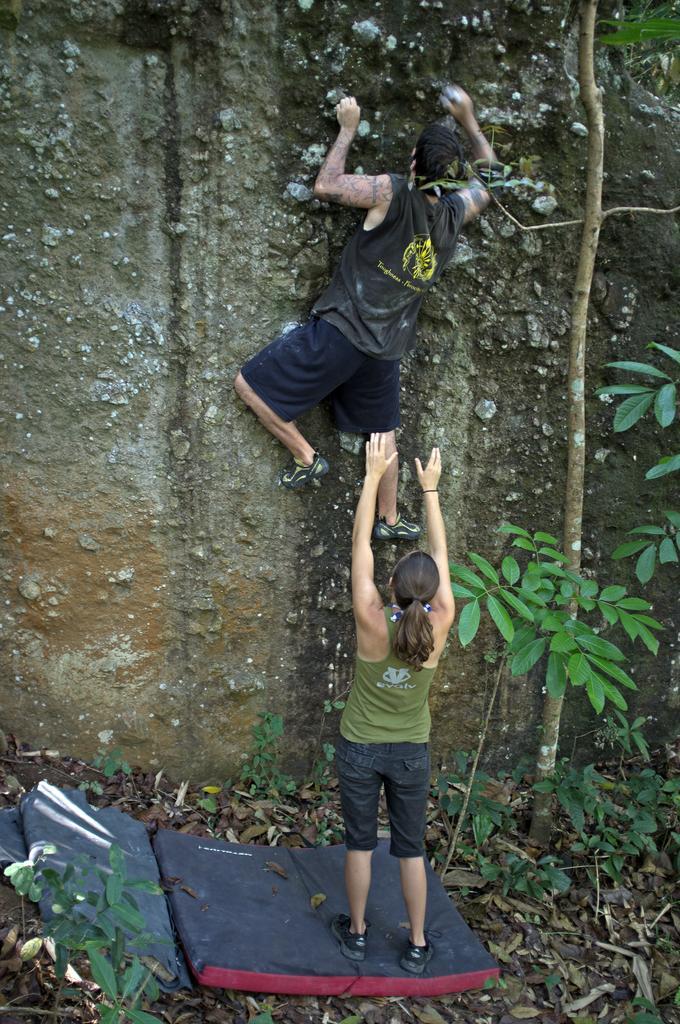Describe this image in one or two sentences. In this picture this 2 person are highlighted. This person is trying to climb a mountain. Beside this woman there is a plant. This woman is standing on a bed. 